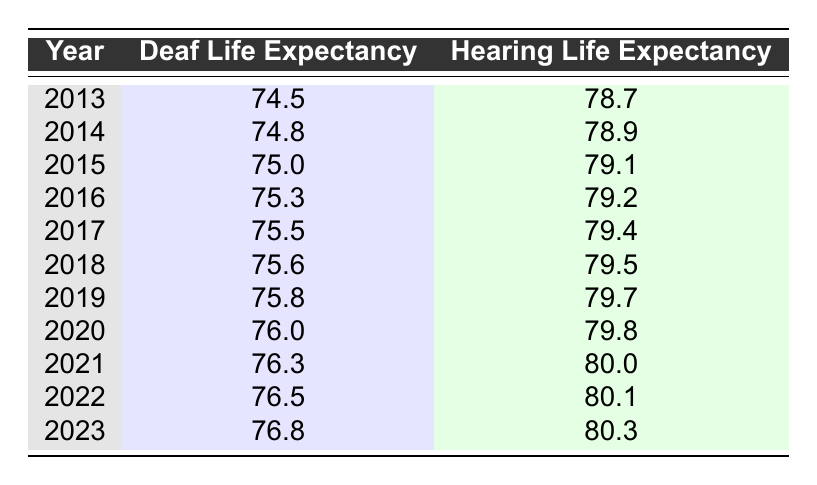What was the deaf life expectancy in 2013? Looking at the row for the year 2013 in the table, the value listed under "Deaf Life Expectancy" is 74.5.
Answer: 74.5 What was the hearing life expectancy in 2020? According to the table, the "Hearing Life Expectancy" for the year 2020 is found in its respective row, which shows a value of 79.8.
Answer: 79.8 In which year did the deaf life expectancy reach 76.0? From the table, the deaf life expectancy first reached 76.0 in the year 2020, as this is the only entry where this value appears.
Answer: 2020 What is the increase in hearing life expectancy from 2013 to 2023? To find the increase, subtract the hearing life expectancy in 2013 (78.7) from the life expectancy in 2023 (80.3). Thus, 80.3 - 78.7 = 1.6 years.
Answer: 1.6 Is the deaf life expectancy higher than the hearing life expectancy in 2015? In the year 2015, the deaf life expectancy is 75.0 while the hearing life expectancy is 79.1. Since 75.0 is not greater than 79.1, the statement is false.
Answer: No What is the average deaf life expectancy over the decade presented? The average is calculated by summing up all deaf life expectancy values from 2013 to 2023, which total 75.04, and then dividing by the number of years, which is 11. Thus, 75.04 / 11 ≈ 76.0.
Answer: 76.0 Which year shows the largest increase in deaf life expectancy compared to the previous year? By examining the differences year by year, the most substantial increase occurs from 2019 to 2020, where the deaf life expectancy increases from 75.8 to 76.0, resulting in a change of 0.2 years.
Answer: 2019 to 2020 Was there any year where the deaf life expectancy was exactly the same as the hearing life expectancy? By inspecting the values in both columns for every year, there is no instance where the deaf life expectancy matches the hearing life expectancy exactly.
Answer: No What is the combined deaf life expectancy for the years 2021 and 2022? To find the combined value, add the deaf life expectancy in 2021 (76.3) and 2022 (76.5), giving a total of 76.3 + 76.5 = 152.8.
Answer: 152.8 